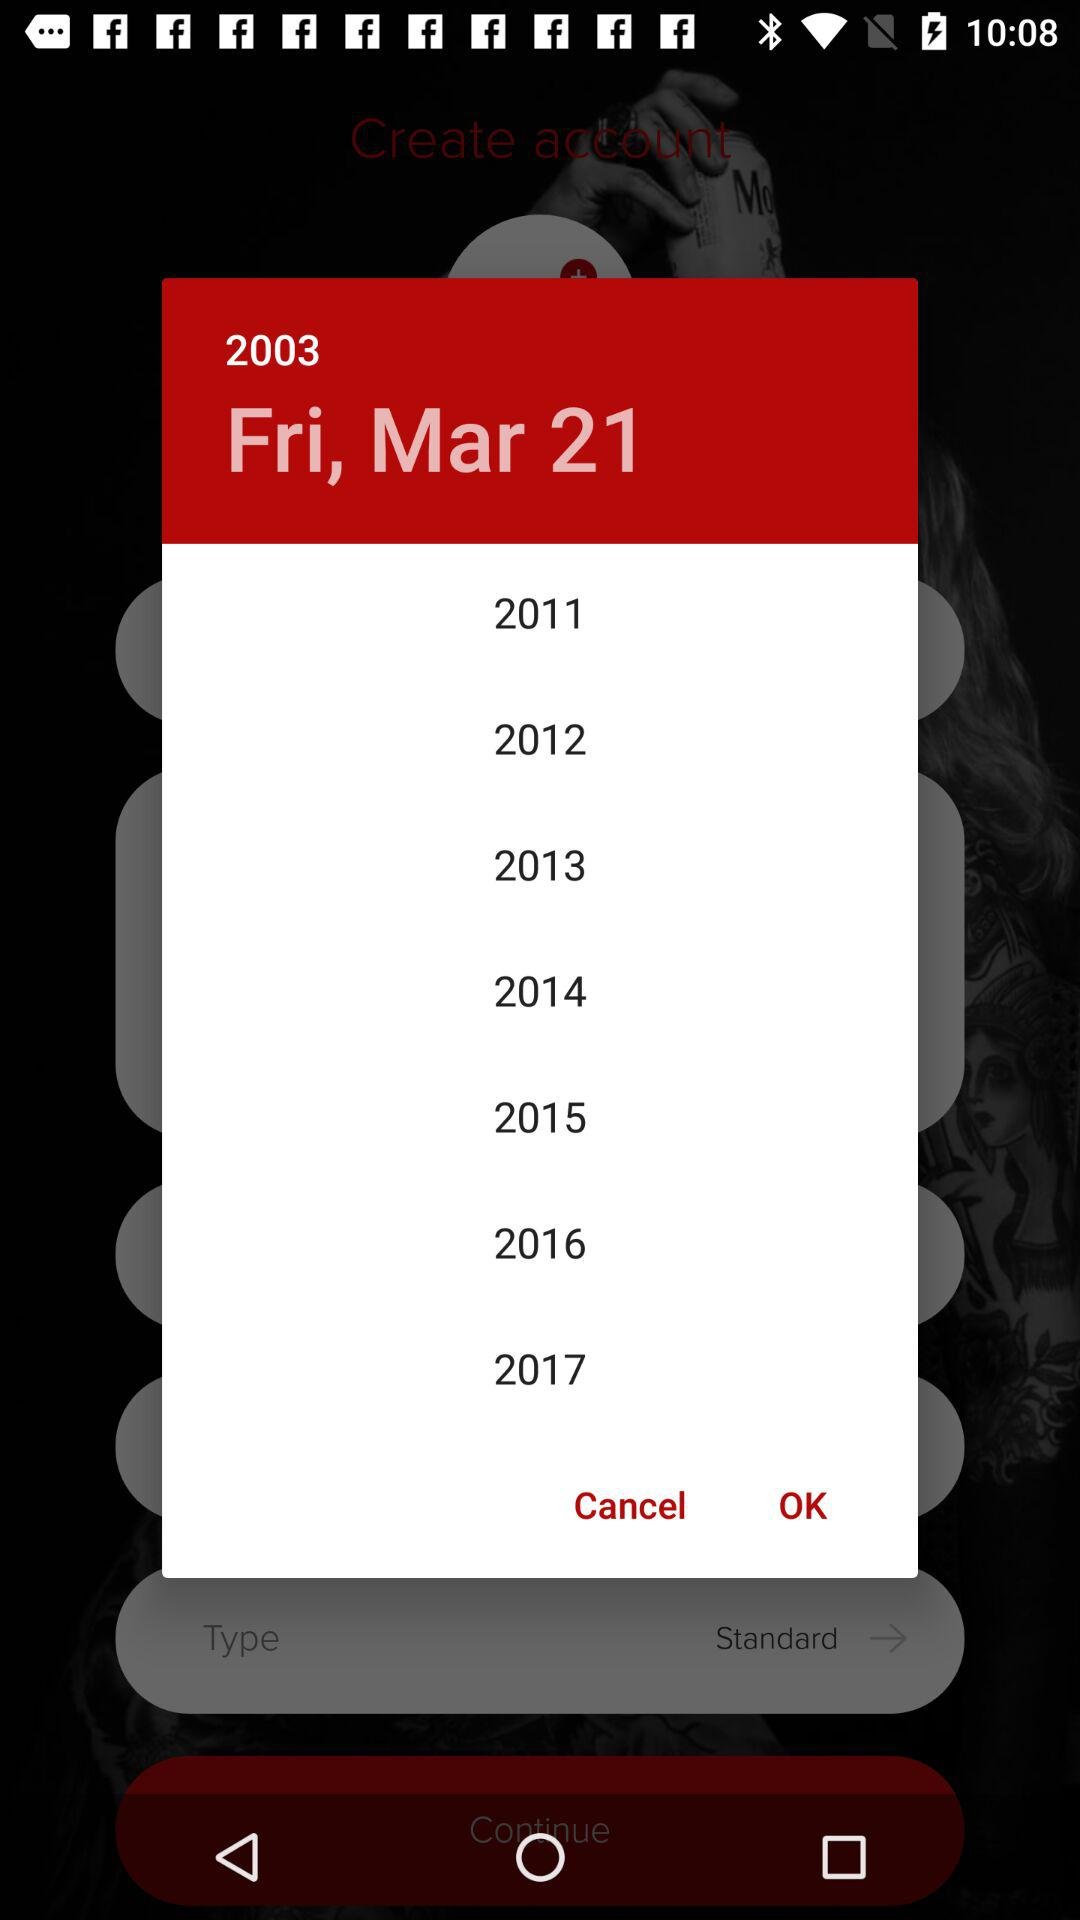What is the day of the selected date? The day is Friday. 